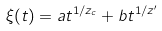Convert formula to latex. <formula><loc_0><loc_0><loc_500><loc_500>\xi ( t ) = a t ^ { 1 / z _ { c } } + b t ^ { 1 / z ^ { \prime } }</formula> 